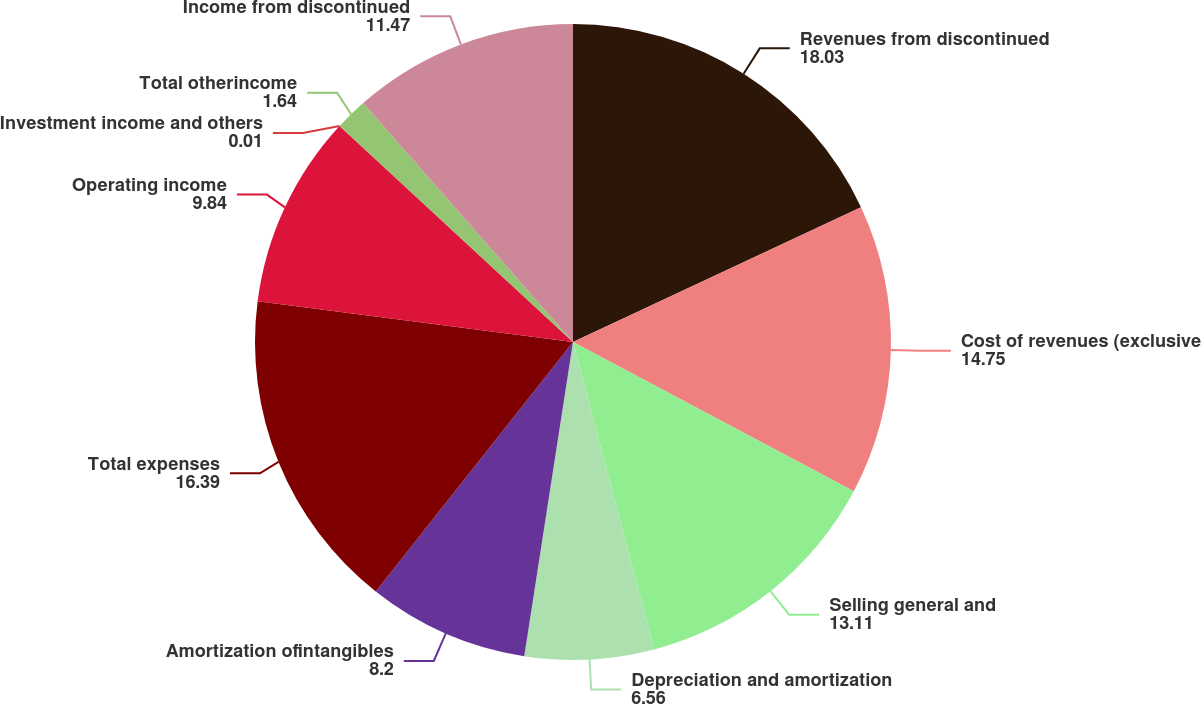<chart> <loc_0><loc_0><loc_500><loc_500><pie_chart><fcel>Revenues from discontinued<fcel>Cost of revenues (exclusive<fcel>Selling general and<fcel>Depreciation and amortization<fcel>Amortization ofintangibles<fcel>Total expenses<fcel>Operating income<fcel>Investment income and others<fcel>Total otherincome<fcel>Income from discontinued<nl><fcel>18.03%<fcel>14.75%<fcel>13.11%<fcel>6.56%<fcel>8.2%<fcel>16.39%<fcel>9.84%<fcel>0.01%<fcel>1.64%<fcel>11.47%<nl></chart> 